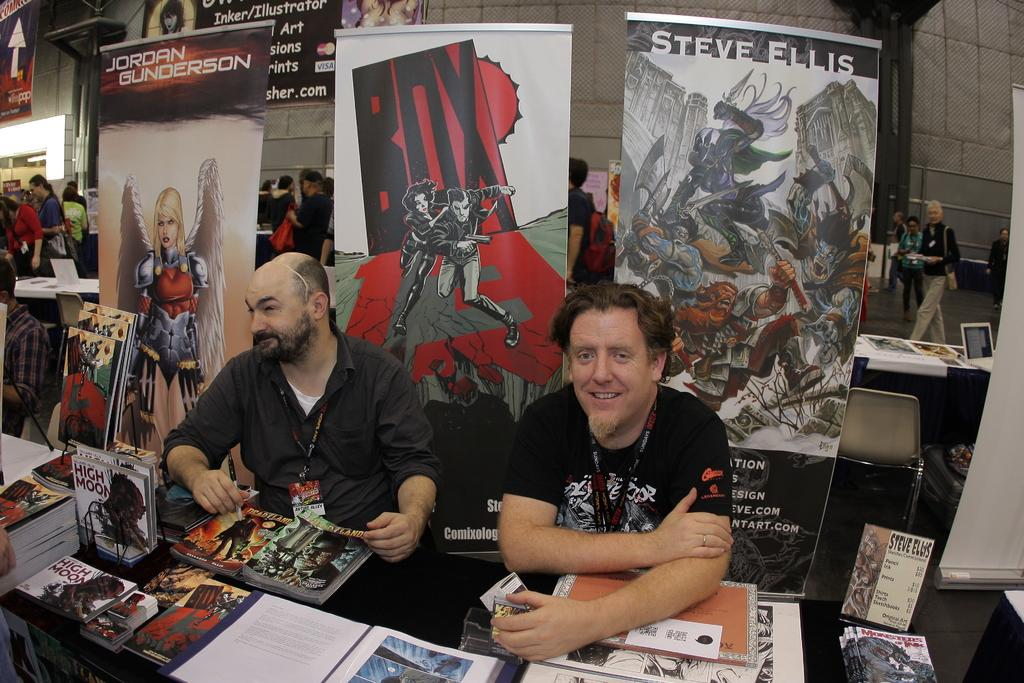<image>
Relay a brief, clear account of the picture shown. Two men sit at a comic book convention table in front of a sign for BOX. 